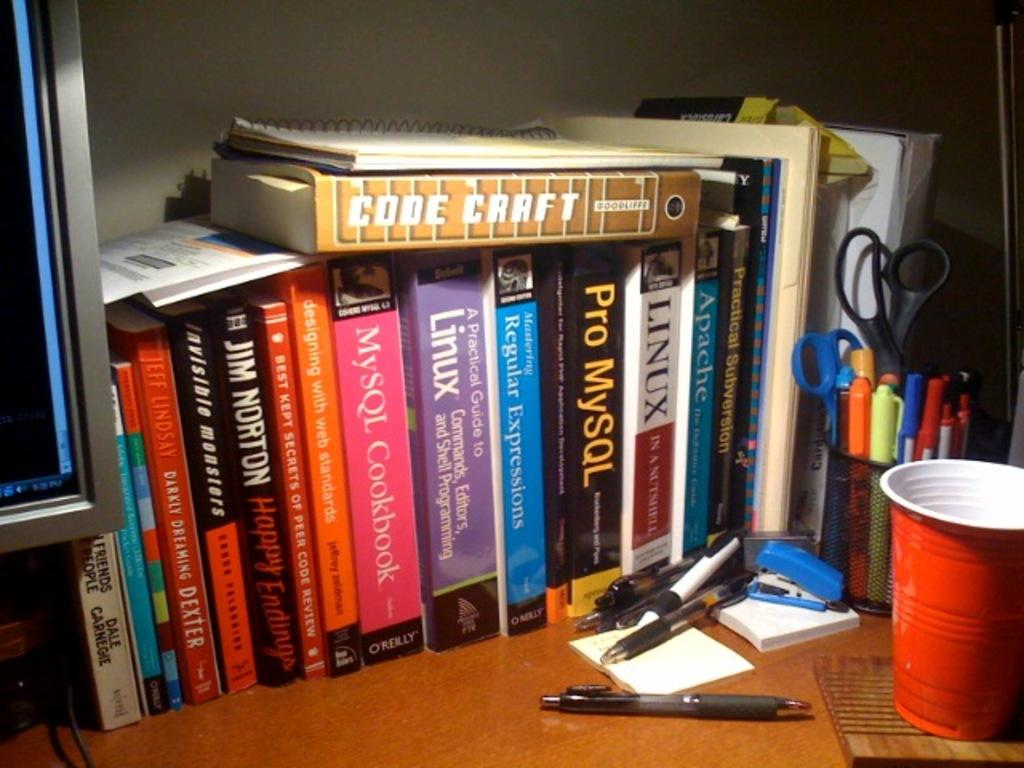<image>
Present a compact description of the photo's key features. A stack of books on a desk with one titled Code Craft. 